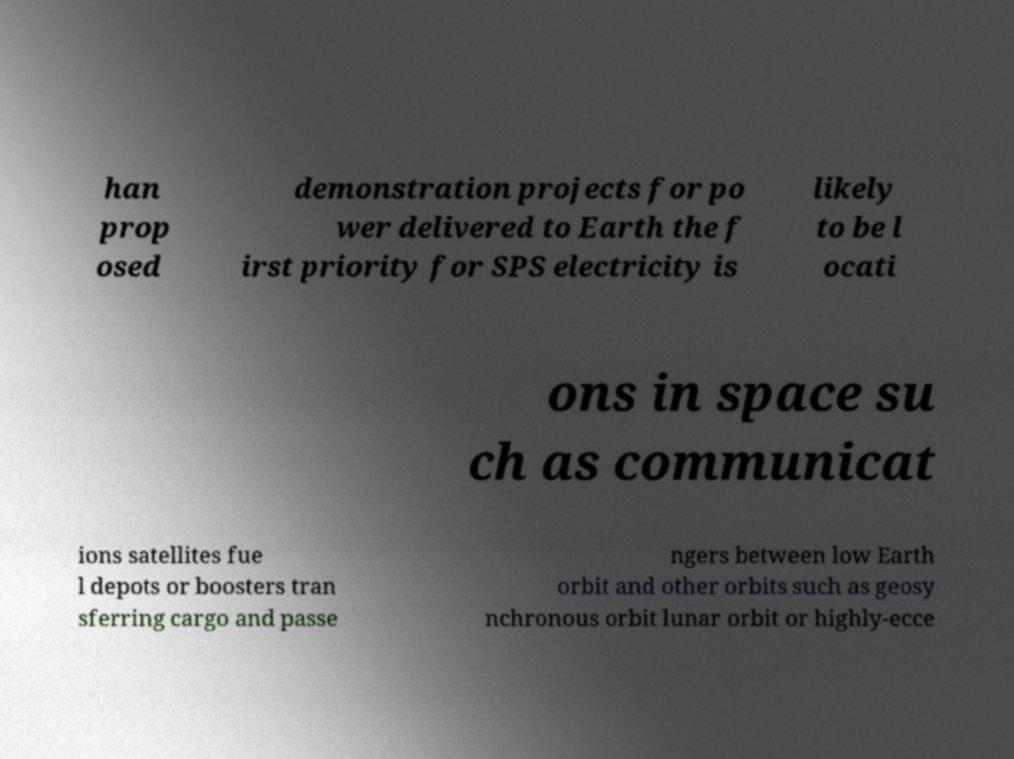There's text embedded in this image that I need extracted. Can you transcribe it verbatim? han prop osed demonstration projects for po wer delivered to Earth the f irst priority for SPS electricity is likely to be l ocati ons in space su ch as communicat ions satellites fue l depots or boosters tran sferring cargo and passe ngers between low Earth orbit and other orbits such as geosy nchronous orbit lunar orbit or highly-ecce 